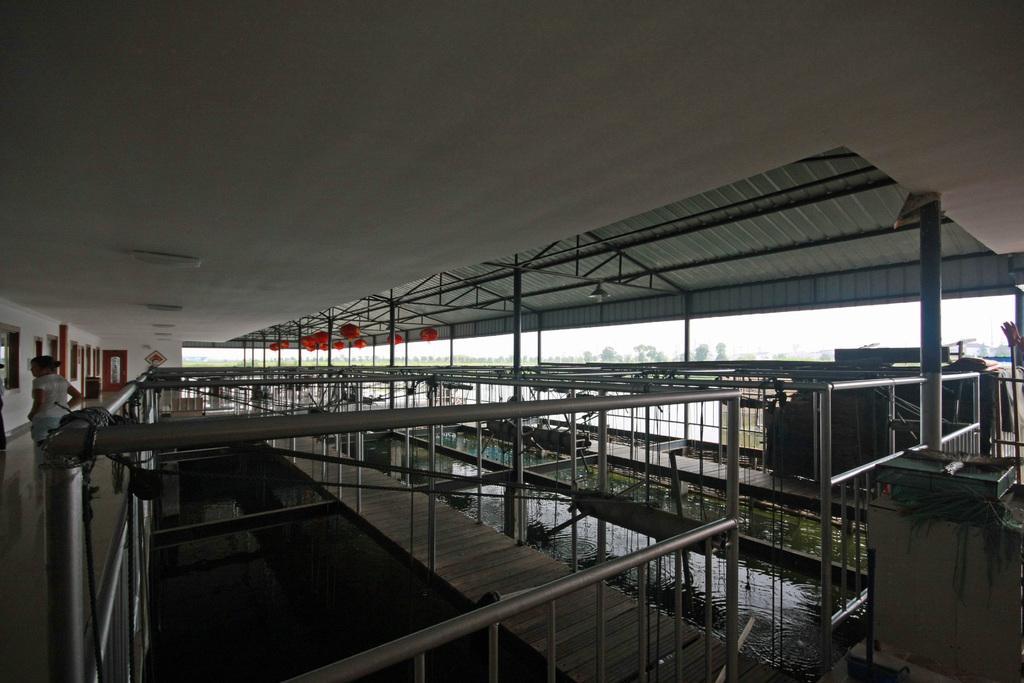Can you describe this image briefly? This picture is taken inside the hall. In this image, on the left side, we can see two people, pillar, glass window, door. On the right side, we can see some pillars. In the middle of the image, we can see metal rods, water. At the top, we can see a roof with few lights, we can also see a metal roof. In the background, we can see some trees and a sky. 